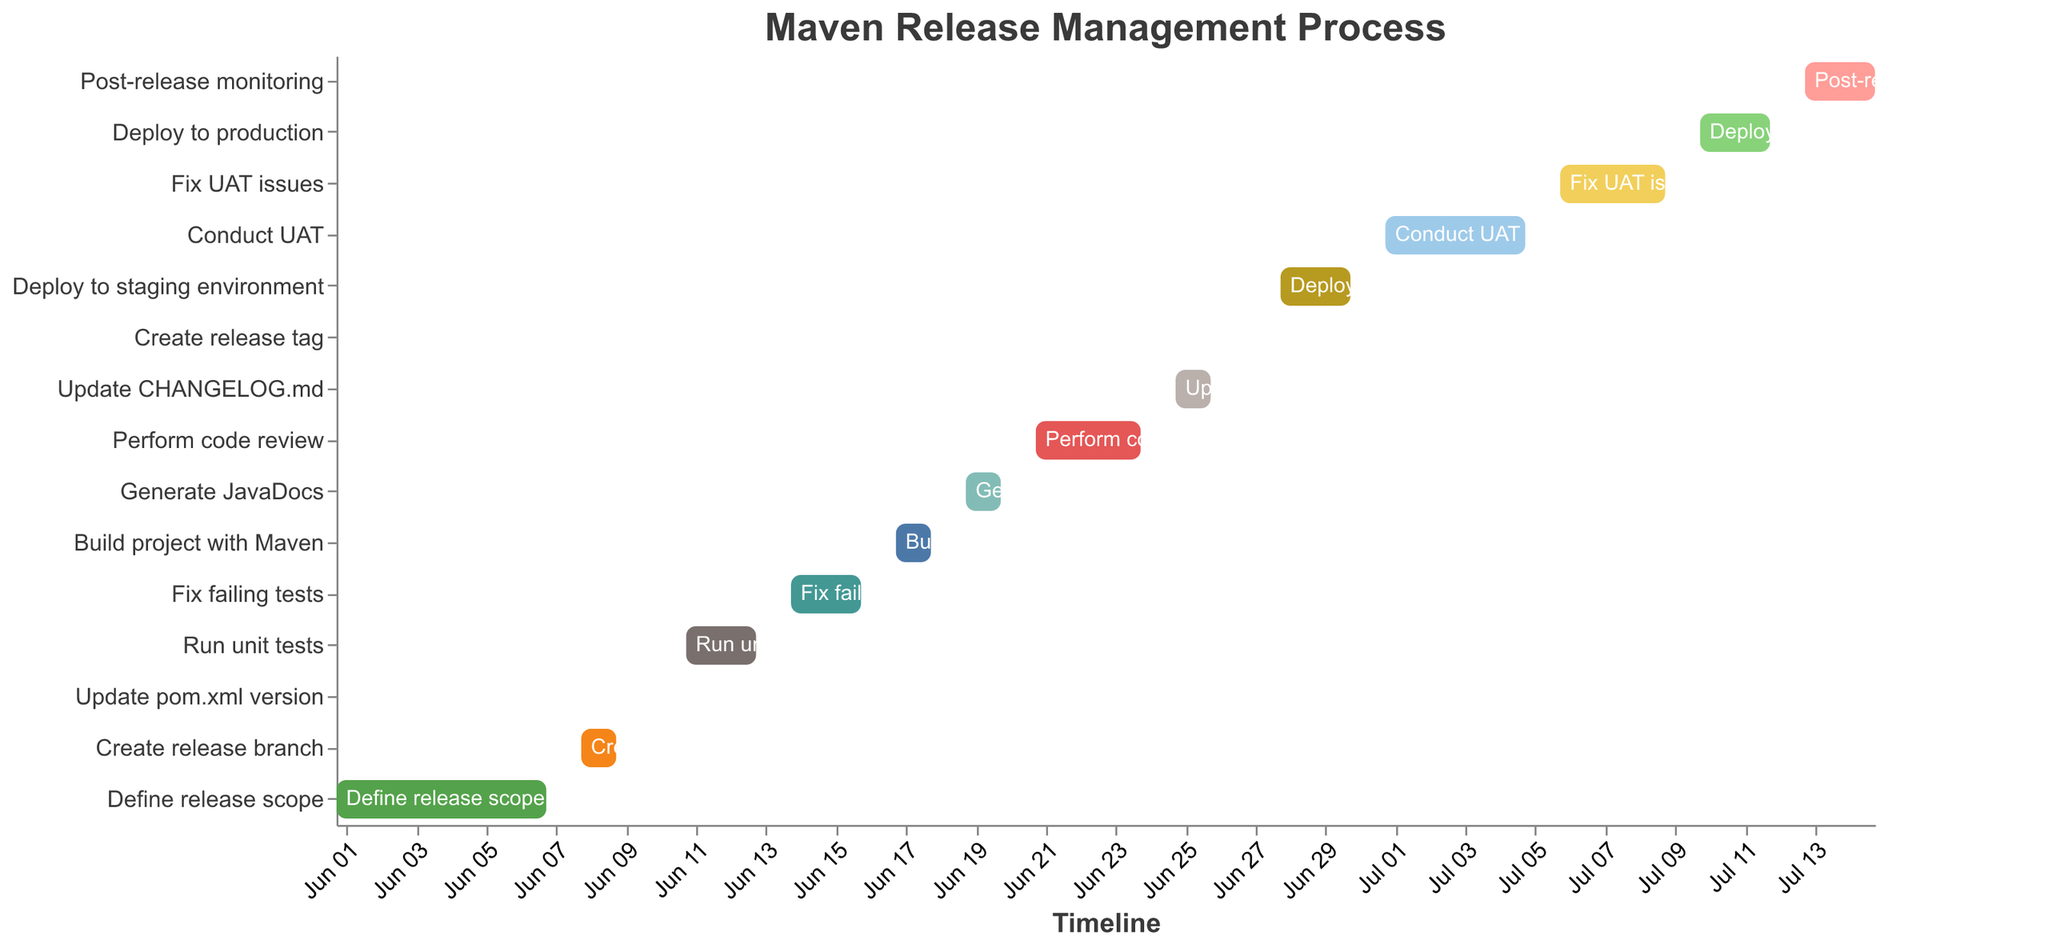What is the title of the Gantt chart? The title is usually positioned at the top of the chart and is used to describe the overall purpose or dataset represented in the chart. Here, the title "Maven Release Management Process" is shown at the top of the figure.
Answer: Maven Release Management Process How many tasks are represented in the Gantt chart? To determine the number of tasks, you can count each distinct bar along the y-axis, which represents individual tasks. By counting, we see there are 15 tasks.
Answer: 15 Which task starts first, and on what date? The task that starts first is placed at the beginning of the timeline on the x-axis. "Define release scope" is the first task, starting on June 1, 2023.
Answer: Define release scope, June 1, 2023 What tasks are dependent on "Run unit tests"? Dependencies are typically implicit in the order of tasks. To identify dependencies, look at subsequent tasks that are scheduled to start after "Run unit tests". These are "Fix failing tests".
Answer: Fix failing tests Which task takes the longest duration to complete? The duration of a task is determined by the length of the bar on the x-axis. In this chart, "Conduct UAT" extends from July 1 to July 5, spanning 5 days. No other task lasts longer.
Answer: Conduct UAT What task is scheduled to occur right after "Deploy to staging environment"? To find this, we look at the tasks listed immediately after "Deploy to staging environment" ends on the timeline. "Conduct UAT" is the task that follows directly after it.
Answer: Conduct UAT How long does "Perform code review" take? The duration of a task can be found by subtracting its start date from its end date. "Perform code review" runs from June 21 to June 24, thus it takes 4 days.
Answer: 4 days Which two tasks have the shortest duration, and what are their respective dates? For shortest duration tasks, look for the bars with the smallest width. "Update pom.xml version" and "Create release tag" each take 1 day (June 10 and June 27 respectively).
Answer: Update pom.xml version: June 10, Create release tag: June 27 Between "Build project with Maven" and "Generate JavaDocs", which task starts earlier? Comparing their start dates on the x-axis, "Build project with Maven" starts on June 17, which is before "Generate JavaDocs" that starts on June 19.
Answer: Build project with Maven What is the duration between the start of "Define release scope" and the end of "Post-release monitoring"? Calculate this by finding the difference between the start of "Define release scope" (June 1) and the end of "Post-release monitoring" (July 15). This spans from June 1 to July 15, which is 45 days in total.
Answer: 45 days 